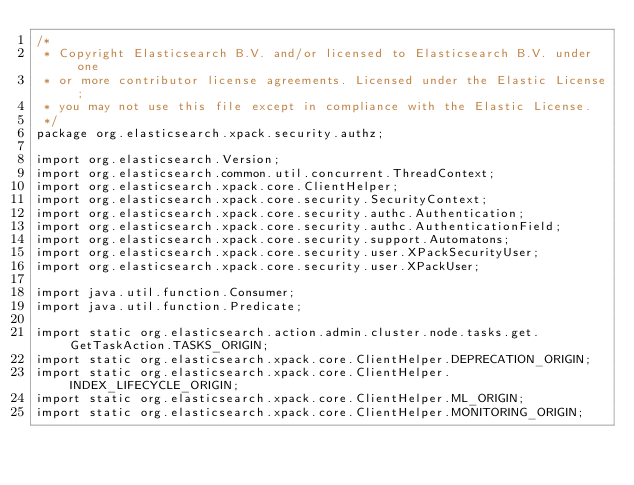Convert code to text. <code><loc_0><loc_0><loc_500><loc_500><_Java_>/*
 * Copyright Elasticsearch B.V. and/or licensed to Elasticsearch B.V. under one
 * or more contributor license agreements. Licensed under the Elastic License;
 * you may not use this file except in compliance with the Elastic License.
 */
package org.elasticsearch.xpack.security.authz;

import org.elasticsearch.Version;
import org.elasticsearch.common.util.concurrent.ThreadContext;
import org.elasticsearch.xpack.core.ClientHelper;
import org.elasticsearch.xpack.core.security.SecurityContext;
import org.elasticsearch.xpack.core.security.authc.Authentication;
import org.elasticsearch.xpack.core.security.authc.AuthenticationField;
import org.elasticsearch.xpack.core.security.support.Automatons;
import org.elasticsearch.xpack.core.security.user.XPackSecurityUser;
import org.elasticsearch.xpack.core.security.user.XPackUser;

import java.util.function.Consumer;
import java.util.function.Predicate;

import static org.elasticsearch.action.admin.cluster.node.tasks.get.GetTaskAction.TASKS_ORIGIN;
import static org.elasticsearch.xpack.core.ClientHelper.DEPRECATION_ORIGIN;
import static org.elasticsearch.xpack.core.ClientHelper.INDEX_LIFECYCLE_ORIGIN;
import static org.elasticsearch.xpack.core.ClientHelper.ML_ORIGIN;
import static org.elasticsearch.xpack.core.ClientHelper.MONITORING_ORIGIN;</code> 